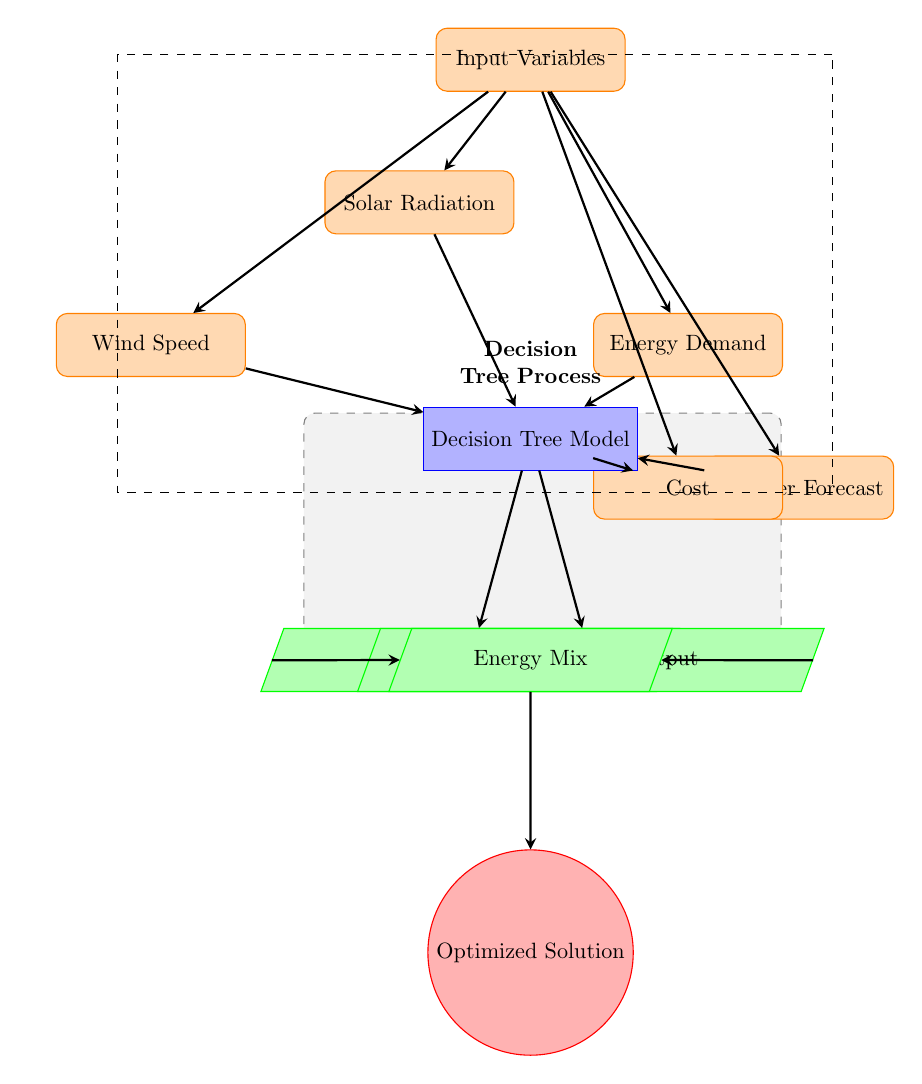What are the input variables in the diagram? The diagram identifies five input variables: Solar Radiation, Wind Speed, Energy Demand, Weather Forecast, and Cost. These can be found at the top of the diagram, each represented in their own rectangular node.
Answer: Solar Radiation, Wind Speed, Energy Demand, Weather Forecast, Cost How many processes are involved in the diagram? The diagram includes one main process represented by the Decision Tree Model node. This can be found below the input variables and is highlighted in blue.
Answer: 1 What is the output of the Decision Tree Model? The output of the Decision Tree Model is divided into two intermediate outputs: Solar Panel Output and Wind Turbine Output, which then combine into the Energy Mix output. The arrows lead from the Decision Tree Model to these outputs and further down to the Energy Mix node.
Answer: Solar Panel Output, Wind Turbine Output What is the final result obtained in the diagram? The final optimized result of the diagram, shown in the red circle at the bottom, is achieved after processing the Energy Mix through the system. It is the last node of the flow.
Answer: Optimized Solution Which input variable directly affects the Energy Mix output? The Energy Mix output is directly influenced by the Solar Panel Output and Wind Turbine Output, both of which stem from the Decision Tree Model process. Therefore, the input variables provide data that leads to these outputs, which then lead to the Energy Mix.
Answer: Solar Panel Output, Wind Turbine Output How many nodes represent input variables in the diagram? There are five distinctive nodes that represent input variables as indicated by the different rectangular nodes positioned at the top of the diagram.
Answer: 5 What type of diagram is being utilized in this context? The diagram is a Machine Learning Diagram, specifically illustrating a Decision Tree process that connects various input variables to derive optimal energy solutions. It uses nodes and arrows to depict the flow of relations and outputs.
Answer: Machine Learning Diagram Which component is directly below the Decision Tree Model? The component that is directly below the Decision Tree Model is labeled as Energy Mix, represented by a trapezium and located directly underneath the Decision Tree node in the flow.
Answer: Energy Mix 